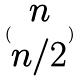<formula> <loc_0><loc_0><loc_500><loc_500>( \begin{matrix} n \\ n / 2 \end{matrix} )</formula> 